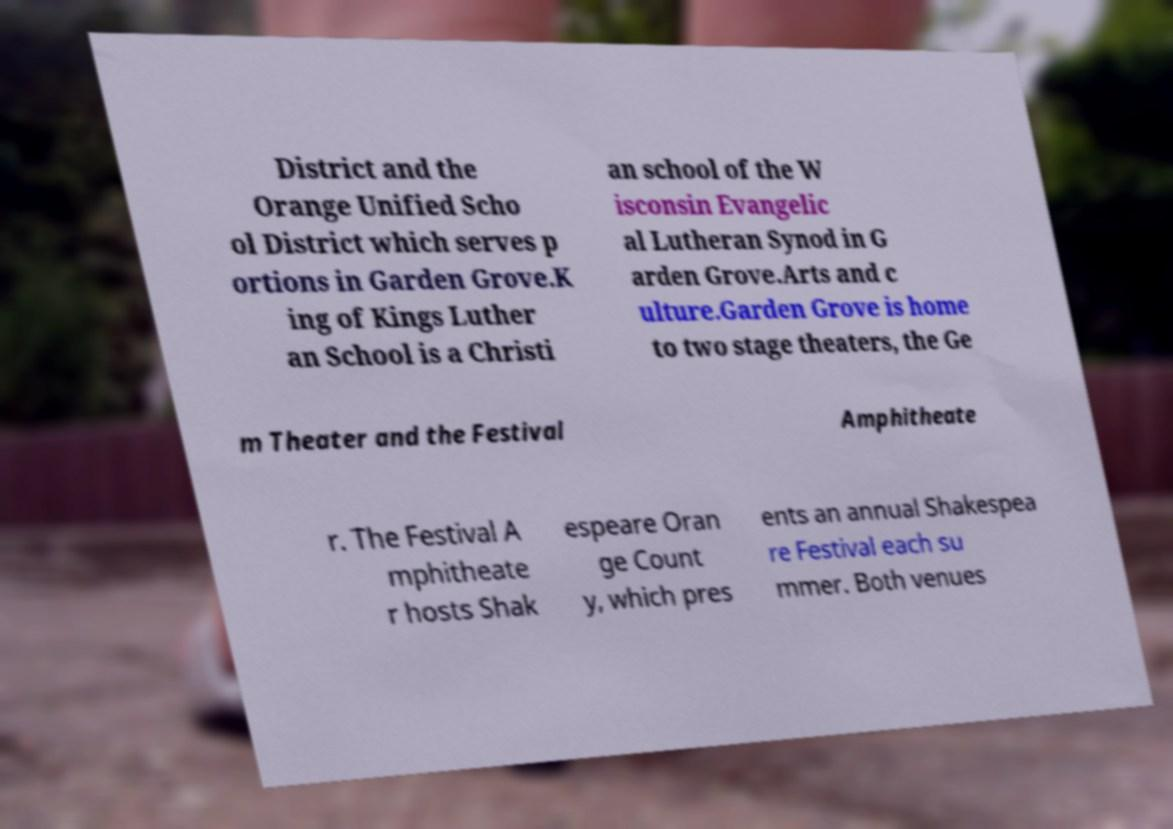There's text embedded in this image that I need extracted. Can you transcribe it verbatim? District and the Orange Unified Scho ol District which serves p ortions in Garden Grove.K ing of Kings Luther an School is a Christi an school of the W isconsin Evangelic al Lutheran Synod in G arden Grove.Arts and c ulture.Garden Grove is home to two stage theaters, the Ge m Theater and the Festival Amphitheate r. The Festival A mphitheate r hosts Shak espeare Oran ge Count y, which pres ents an annual Shakespea re Festival each su mmer. Both venues 